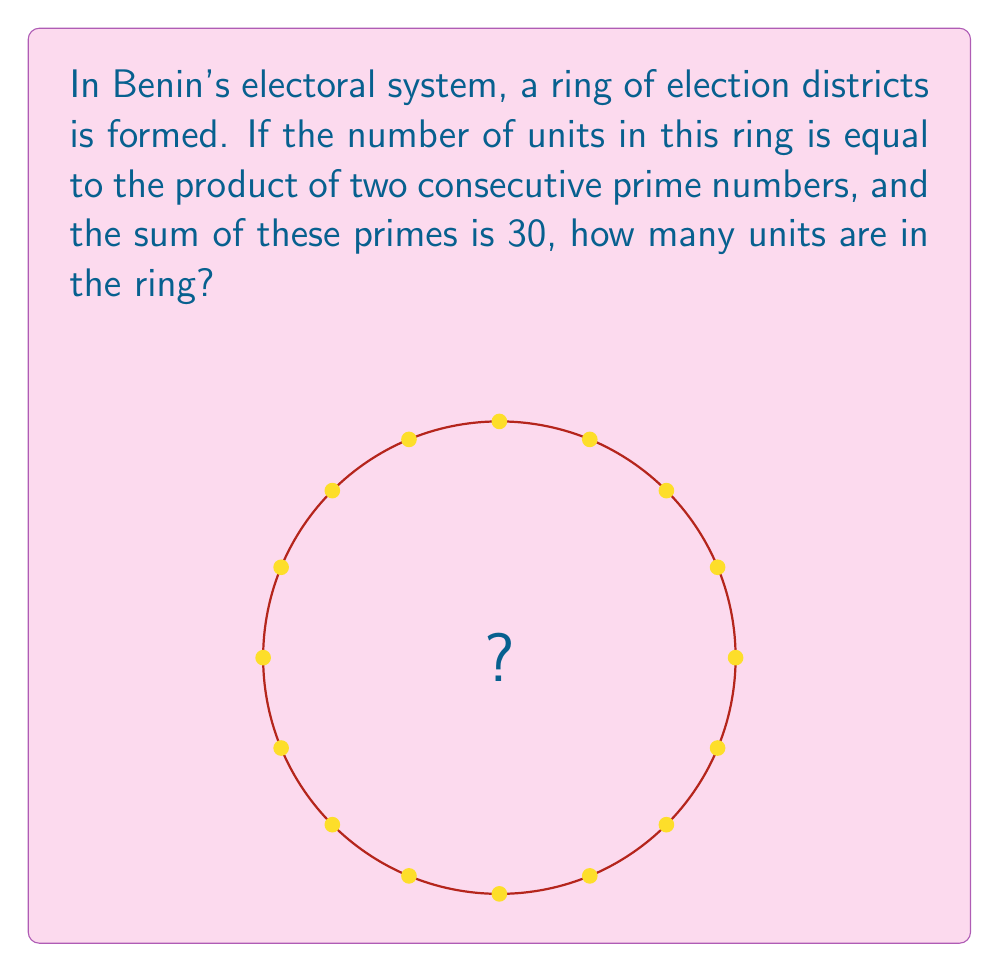Can you solve this math problem? Let's approach this step-by-step:

1) We're told that the number of units is the product of two consecutive prime numbers.

2) We're also given that the sum of these primes is 30.

3) Let's call these primes $p$ and $q$, where $q = p + 2$ (since they're consecutive primes).

4) We can set up the equation:

   $p + q = 30$

5) Substituting $q = p + 2$:

   $p + (p + 2) = 30$

6) Simplifying:

   $2p + 2 = 30$
   $2p = 28$
   $p = 14$

7) Therefore, $q = p + 2 = 16$

8) We need to verify that both 14 and 16 are prime. 14 is not prime, so we need to try the next pair of primes that sum to 30.

9) The next pair is 13 and 17, which are both prime.

10) The number of units in the ring is thus:

    $13 * 17 = 221$

Therefore, there are 221 units in the ring of election districts.
Answer: 221 